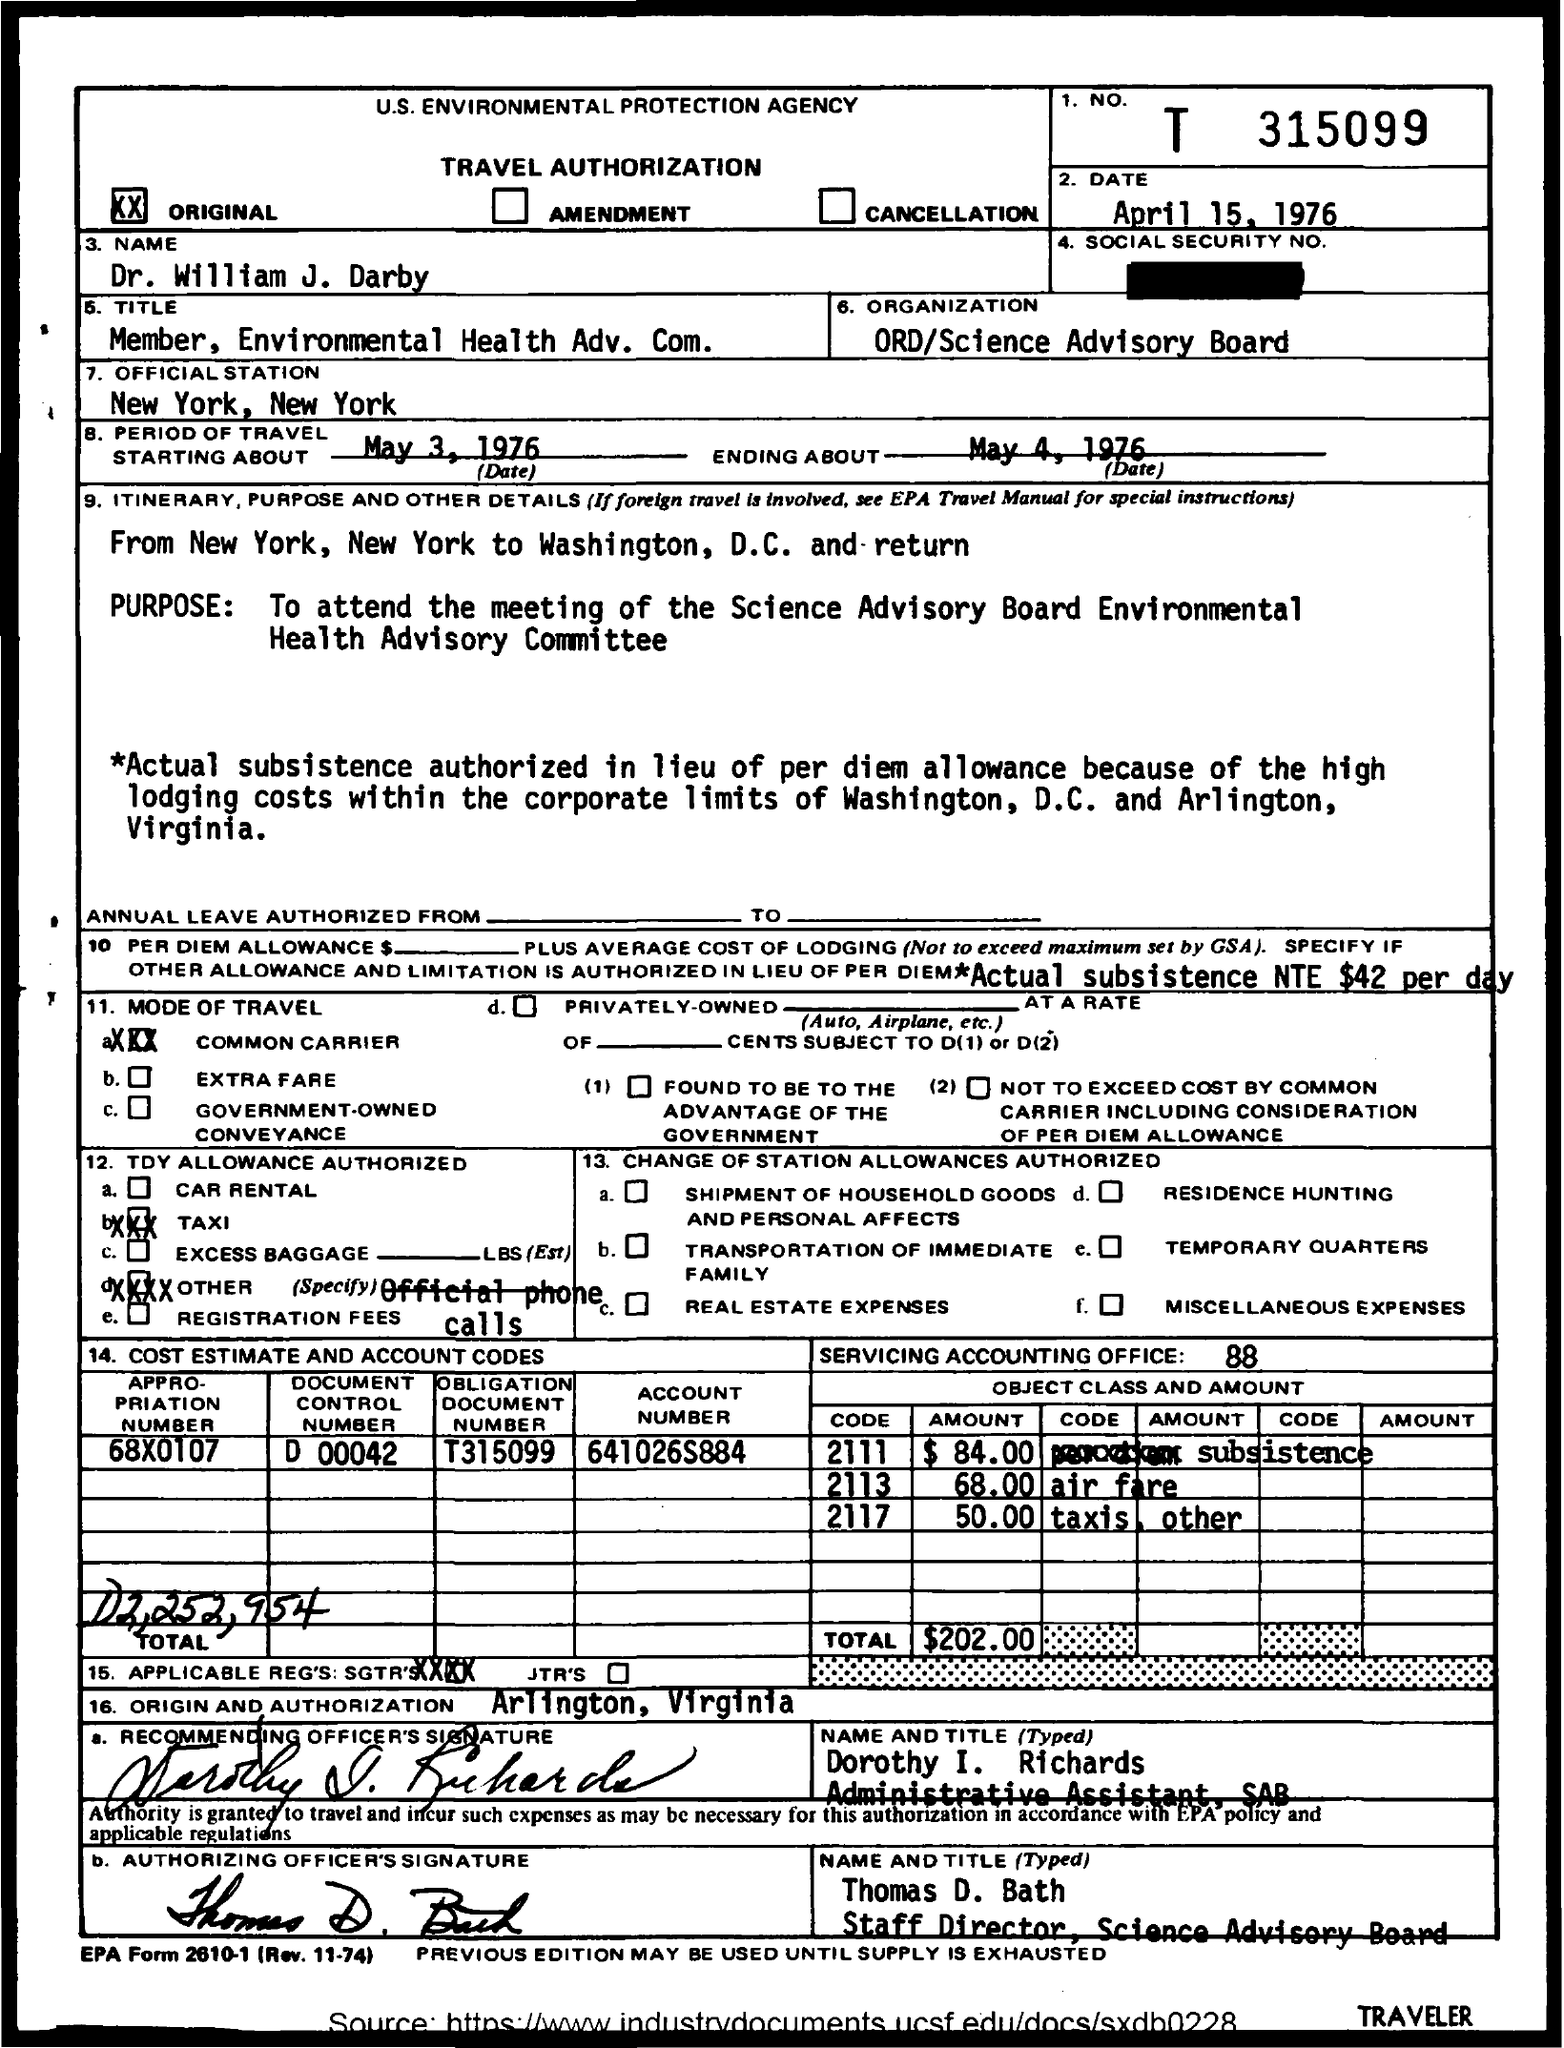What is this form for?
Provide a succinct answer. TRAVEL AUTHORIZATION. When the PERIOD OF TRAVEL starts?
Make the answer very short. May 3, 1976. Whats the PURPOSE  of travel?
Your answer should be very brief. To attend the meeting of Science Advisory Board Environmental Health Advisory Committee. When was the form submitted?
Your answer should be very brief. April 15, 1976. Whats the ENDING ABOUT Travel?
Your response must be concise. May 4, 1976. 